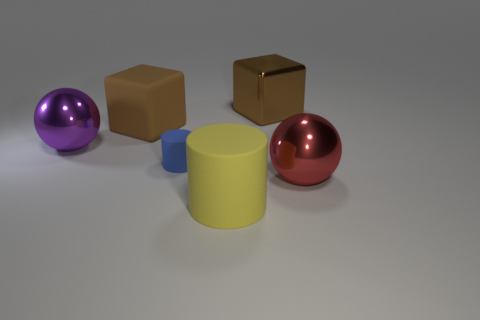Add 1 matte things. How many objects exist? 7 Subtract all cylinders. How many objects are left? 4 Add 1 large purple shiny objects. How many large purple shiny objects exist? 2 Subtract 1 red spheres. How many objects are left? 5 Subtract all small blue things. Subtract all large purple balls. How many objects are left? 4 Add 6 yellow objects. How many yellow objects are left? 7 